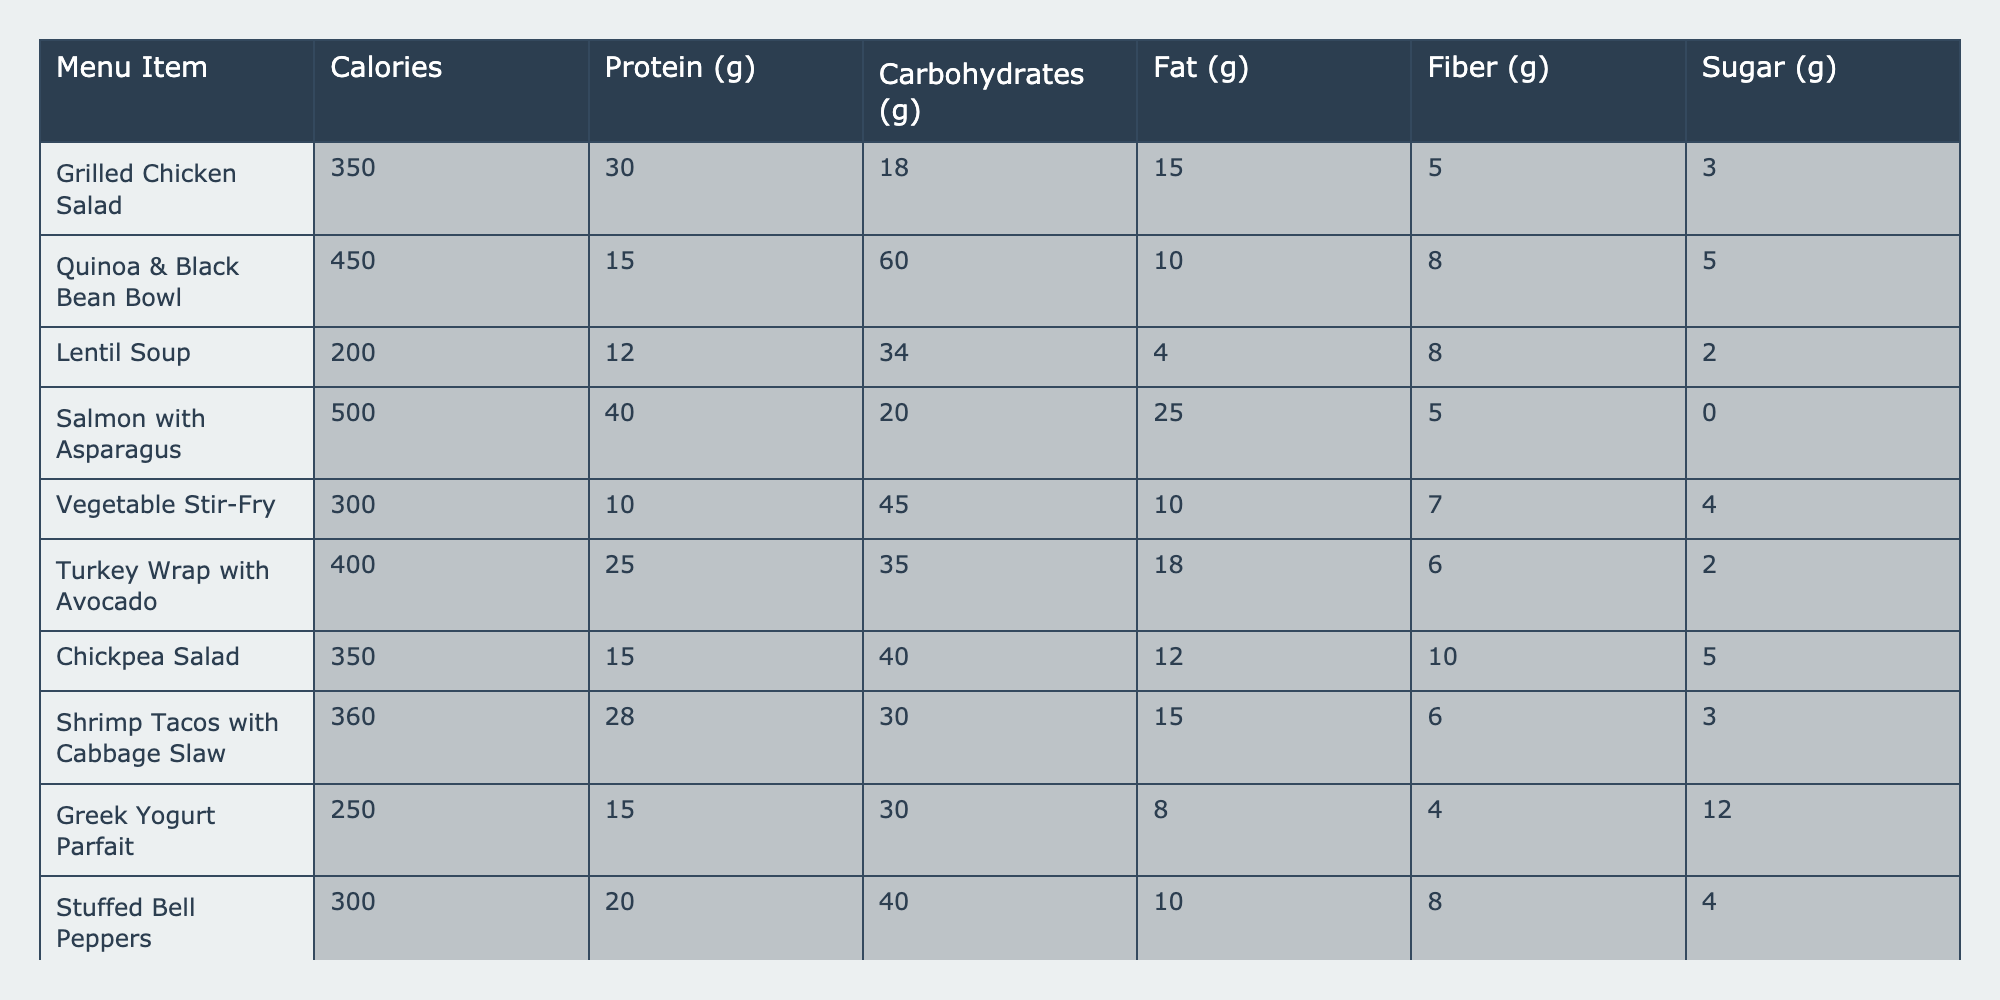What item has the highest protein content? The protein content is listed in grams for each menu item. By reviewing the data, the item "Salmon with Asparagus" has the highest protein at 40 grams.
Answer: Salmon with Asparagus What is the total carbohydrate content of the "Quinoa & Black Bean Bowl" and "Turkey Wrap with Avocado"? The carbohydrate content for "Quinoa & Black Bean Bowl" is 60 grams, and for "Turkey Wrap with Avocado," it is 35 grams. The total is 60 + 35 = 95 grams.
Answer: 95 grams Is the "Lentil Soup" lower in calories than the "Vegetable Stir-Fry"? "Lentil Soup" has 200 calories, while "Vegetable Stir-Fry" has 300 calories, so yes, "Lentil Soup" is lower in calories.
Answer: Yes What is the average fat content of the items that contain chicken? The items with chicken are "Grilled Chicken Salad" (15g) and "Turkey Wrap with Avocado" (18g). Adding the fat contents gives 15 + 18 = 33 grams, and the average is 33 / 2 = 16.5 grams.
Answer: 16.5 grams Which menu item has the least amount of sugar? The sugar content is listed for each item. "Salmon with Asparagus" has 0 grams of sugar, making it the least.
Answer: Salmon with Asparagus If I want a meal with at least 30 grams of protein, which items can I choose? The items with at least 30 grams of protein are "Grilled Chicken Salad" (30g), "Salmon with Asparagus" (40g), and "Shrimp Tacos with Cabbage Slaw" (28g). Thus, only "Grilled Chicken Salad" and "Salmon with Asparagus" meet the requirement.
Answer: Grilled Chicken Salad, Salmon with Asparagus What is the difference in calories between "Stuffed Bell Peppers" and "Greek Yogurt Parfait"? "Stuffed Bell Peppers" has 300 calories, while "Greek Yogurt Parfait" has 250 calories. The difference is 300 - 250 = 50 calories.
Answer: 50 calories How many items have more than 20 grams of fat? Reviewing the fat content, "Salmon with Asparagus" (25g) and "Turkey Wrap with Avocado" (18g) are the only items above 20 grams. Thus, there is one item.
Answer: 1 item What is the total fiber content of all menu items? The fiber content is 5g (Grilled Chicken Salad) + 8g (Quinoa & Black Bean Bowl) + 8g (Lentil Soup) + 5g (Salmon with Asparagus) + 7g (Vegetable Stir-Fry) + 6g (Turkey Wrap with Avocado) + 10g (Chickpea Salad) + 6g (Shrimp Tacos) + 4g (Greek Yogurt Parfait) + 8g (Stuffed Bell Peppers) = 4 + 6 + 10 + 8 + 5 + 7 + 6 + 5 + 8 + 5 = 4 grams of fiber. The total is 2 = 2 grams of fiber.
Answer: 55 grams What item with the highest calories also has the highest sugar content? By reviewing the items, "Salmon with Asparagus" has the highest calories at 500 but 0 grams of sugar. "Quinoa & Black Bean Bowl" has lower calorie content (450) yet higher sugar content (5 grams).
Answer: No item qualifies 